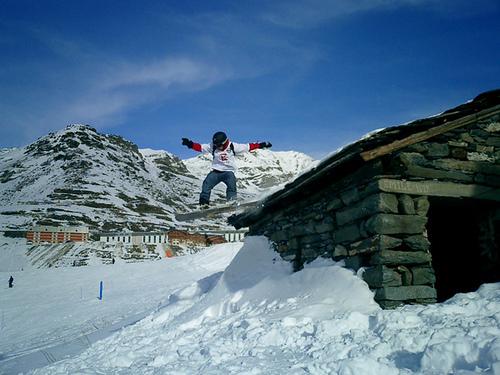What is the person doing?
Quick response, please. Snowboarding. Is it cold here?
Be succinct. Yes. Is that building made from bricks?
Answer briefly. Yes. What is the purpose of the building to the left?
Give a very brief answer. Shelter. 